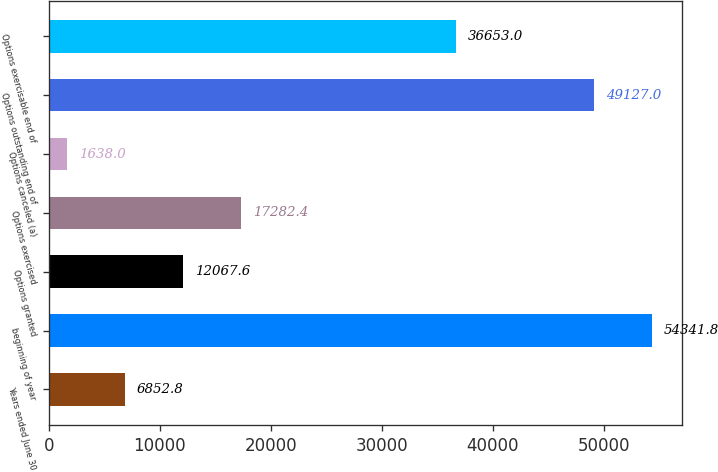<chart> <loc_0><loc_0><loc_500><loc_500><bar_chart><fcel>Years ended June 30<fcel>beginning of year<fcel>Options granted<fcel>Options exercised<fcel>Options canceled (a)<fcel>Options outstanding end of<fcel>Options exercisable end of<nl><fcel>6852.8<fcel>54341.8<fcel>12067.6<fcel>17282.4<fcel>1638<fcel>49127<fcel>36653<nl></chart> 